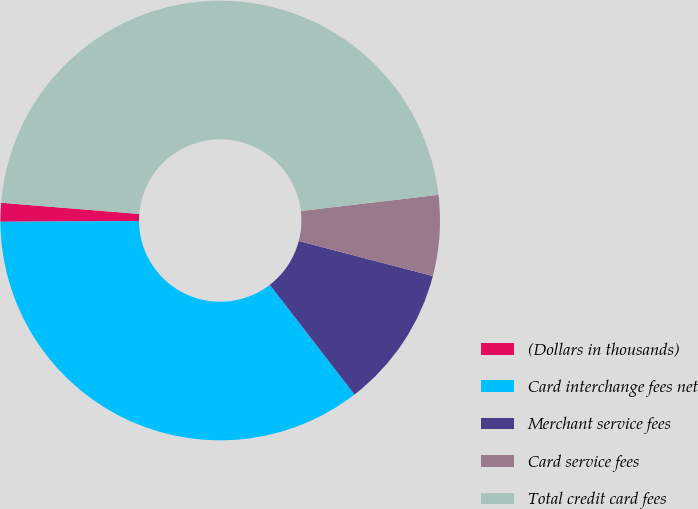Convert chart. <chart><loc_0><loc_0><loc_500><loc_500><pie_chart><fcel>(Dollars in thousands)<fcel>Card interchange fees net<fcel>Merchant service fees<fcel>Card service fees<fcel>Total credit card fees<nl><fcel>1.38%<fcel>35.37%<fcel>10.47%<fcel>5.93%<fcel>46.84%<nl></chart> 